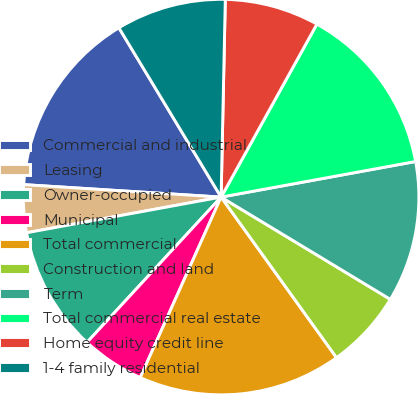Convert chart to OTSL. <chart><loc_0><loc_0><loc_500><loc_500><pie_chart><fcel>Commercial and industrial<fcel>Leasing<fcel>Owner-occupied<fcel>Municipal<fcel>Total commercial<fcel>Construction and land<fcel>Term<fcel>Total commercial real estate<fcel>Home equity credit line<fcel>1-4 family residential<nl><fcel>15.35%<fcel>3.89%<fcel>10.25%<fcel>5.16%<fcel>16.62%<fcel>6.43%<fcel>11.53%<fcel>14.07%<fcel>7.71%<fcel>8.98%<nl></chart> 